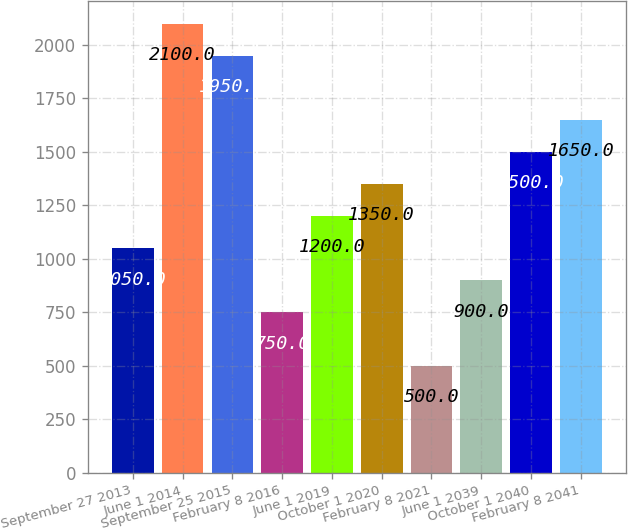Convert chart. <chart><loc_0><loc_0><loc_500><loc_500><bar_chart><fcel>September 27 2013<fcel>June 1 2014<fcel>September 25 2015<fcel>February 8 2016<fcel>June 1 2019<fcel>October 1 2020<fcel>February 8 2021<fcel>June 1 2039<fcel>October 1 2040<fcel>February 8 2041<nl><fcel>1050<fcel>2100<fcel>1950<fcel>750<fcel>1200<fcel>1350<fcel>500<fcel>900<fcel>1500<fcel>1650<nl></chart> 